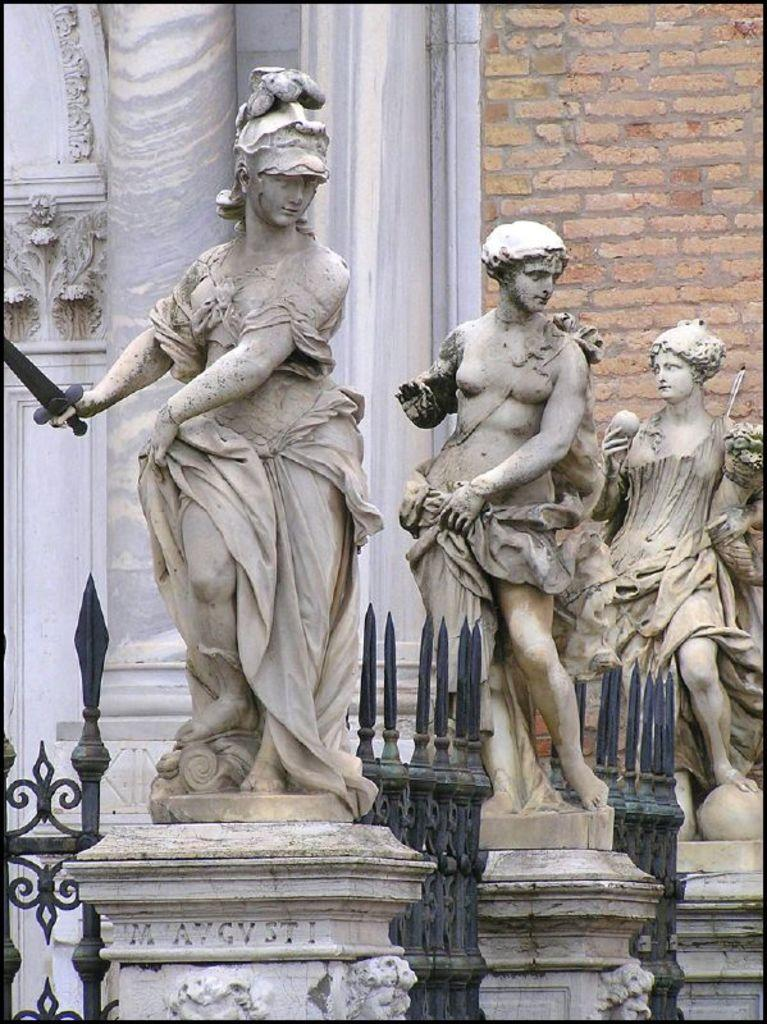What can be seen on top of the pillars in the image? There are statues on pillars in the image. What type of barrier is visible in the image? There is a fence visible in the image. What architectural feature can be seen in the image? There is a wall in the image. Where are the sculptures located in the image? The sculptures are on the left side of the image. Can you describe the mask that the woman is wearing while feeding the goldfish in the image? There is no woman, mask, or goldfish present in the image. The image features statues on pillars, a fence, a wall, and sculptures on the left side. 